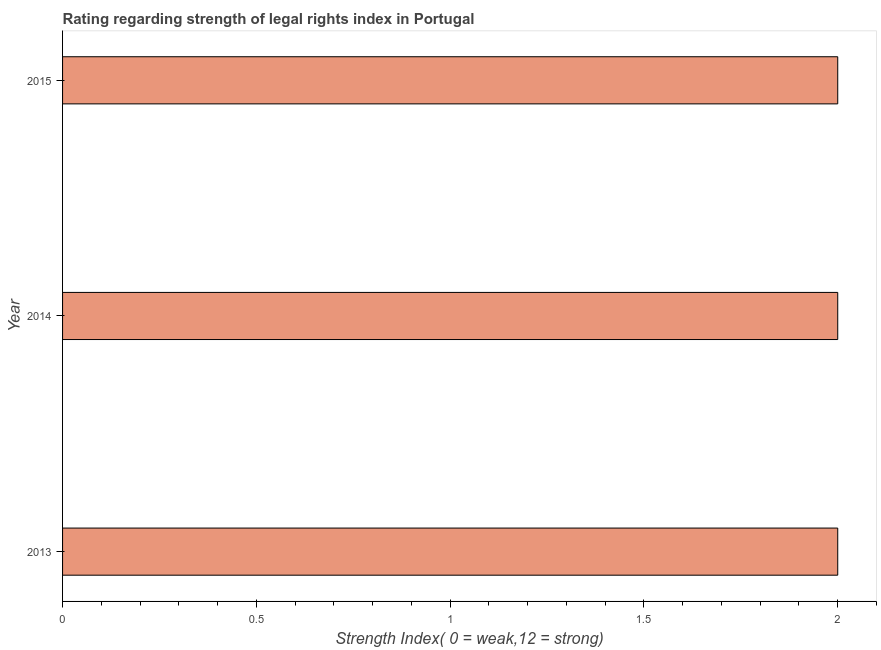Does the graph contain any zero values?
Give a very brief answer. No. What is the title of the graph?
Give a very brief answer. Rating regarding strength of legal rights index in Portugal. What is the label or title of the X-axis?
Keep it short and to the point. Strength Index( 0 = weak,12 = strong). What is the label or title of the Y-axis?
Offer a terse response. Year. What is the strength of legal rights index in 2014?
Keep it short and to the point. 2. Across all years, what is the maximum strength of legal rights index?
Your answer should be very brief. 2. Across all years, what is the minimum strength of legal rights index?
Provide a succinct answer. 2. What is the difference between the strength of legal rights index in 2013 and 2015?
Your response must be concise. 0. What is the average strength of legal rights index per year?
Offer a terse response. 2. What is the median strength of legal rights index?
Provide a short and direct response. 2. In how many years, is the strength of legal rights index greater than 1.1 ?
Provide a short and direct response. 3. What is the ratio of the strength of legal rights index in 2013 to that in 2015?
Give a very brief answer. 1. Is the strength of legal rights index in 2014 less than that in 2015?
Your answer should be compact. No. Is the difference between the strength of legal rights index in 2013 and 2014 greater than the difference between any two years?
Provide a short and direct response. Yes. What is the difference between the highest and the second highest strength of legal rights index?
Offer a very short reply. 0. What is the difference between the highest and the lowest strength of legal rights index?
Your answer should be very brief. 0. In how many years, is the strength of legal rights index greater than the average strength of legal rights index taken over all years?
Your response must be concise. 0. Are all the bars in the graph horizontal?
Provide a succinct answer. Yes. What is the Strength Index( 0 = weak,12 = strong) in 2013?
Your answer should be very brief. 2. What is the difference between the Strength Index( 0 = weak,12 = strong) in 2013 and 2014?
Provide a short and direct response. 0. What is the difference between the Strength Index( 0 = weak,12 = strong) in 2014 and 2015?
Keep it short and to the point. 0. What is the ratio of the Strength Index( 0 = weak,12 = strong) in 2013 to that in 2015?
Make the answer very short. 1. 